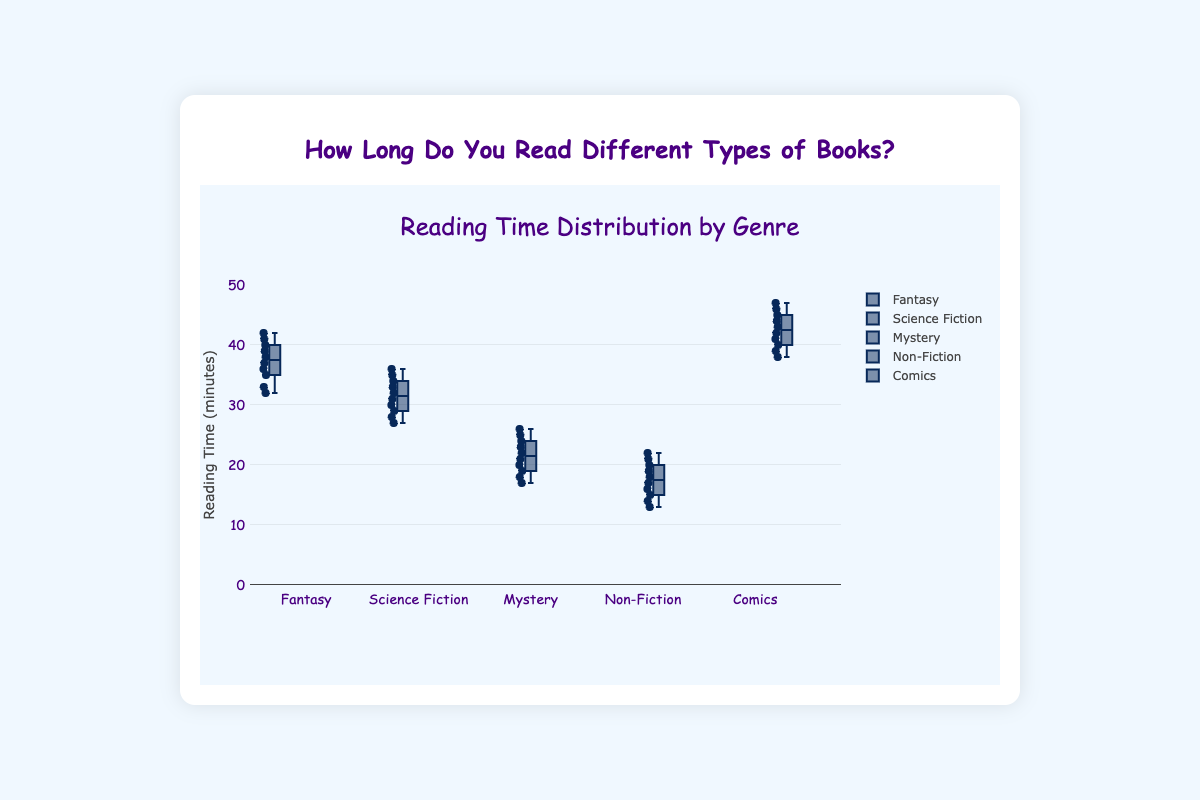What is the title of the box plot? The title is usually displayed at the top of the plot, clearly stating what the plot is about. In this case, the title is "How Long Do You Read Different Types of Books?" which summarizes the contents of the box plot.
Answer: How Long Do You Read Different Types of Books? Which genre has the highest median reading time? In a box plot, the median reading time is represented by the line inside the box. The genre with the highest median will be the one whose median line is positioned higher than the others.
Answer: Comics How many genres have a median reading time above 30 minutes? To determine this, look at the median lines within the boxes of each genre and see which ones are above the 30-minute mark on the reading time axis.
Answer: 3 What is the range of reading times for the Mystery genre? The range of a box plot is defined by the distance between the lowest and highest values (whiskers). For the Mystery genre, the lowest and highest values are the ends of the whiskers.
Answer: 17 to 26 Which genre has the smallest interquartile range (IQR)? The interquartile range is the distance between the first quartile (bottom of the box) and the third quartile (top of the box). The genre with the smallest IQR will have the shortest box.
Answer: Non-Fiction What are the upper whisker values for Fantasy and Non-Fiction? The upper whisker values are the highest points that are not considered outliers. These are the top ends of the whiskers in the Fantasy and Non-Fiction box plots.
Answer: 42 (Fantasy) and 22 (Non-Fiction) Compare the median reading times of Science Fiction and Mystery genres. Which is higher and by how much? Look at the medians (middle line inside the boxes) for both genres and find the difference. Median of Science Fiction is around 31, and Mystery is around 21. The difference is 31 - 21 = 10 minutes.
Answer: Science Fiction is higher by 10 minutes Identify which genre has the most outliers, if any. Outliers are the points that fall outside the whiskers, often marked individually. Count the number of these points for each genre.
Answer: No outliers Which genre has the lowest median reading time? The lowest median reading time is indicated by the lowest middle line inside the box plot of the respective genre.
Answer: Non-Fiction What is the interquartile range (IQR) for the Fantasy genre? The interquartile range is the difference between the third quartile (top of the box) and the first quartile (bottom of the box). For Fantasy, subtract the first quartile value from the third quartile value.
Answer: 38 - 34 = 4 